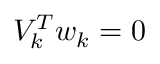Convert formula to latex. <formula><loc_0><loc_0><loc_500><loc_500>V _ { k } ^ { T } w _ { k } = 0</formula> 